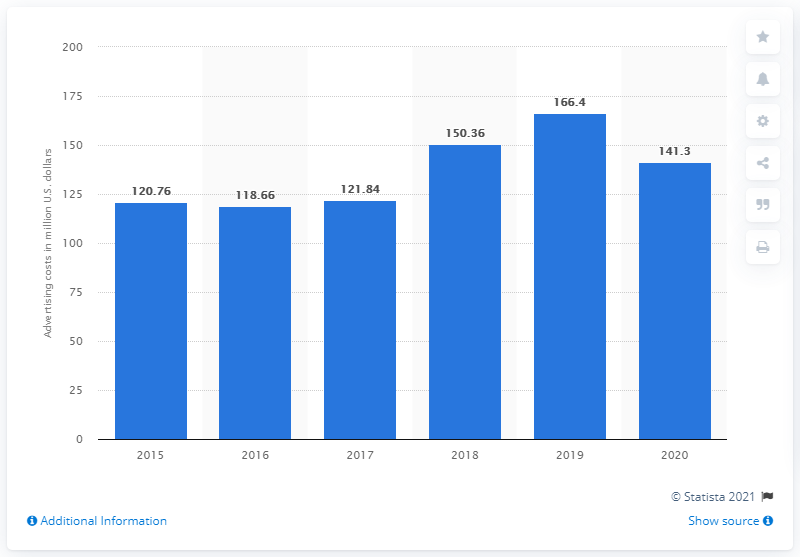Specify some key components in this picture. Columbia Sportswear Company's advertising costs in 2020 were approximately $141.3 million. 